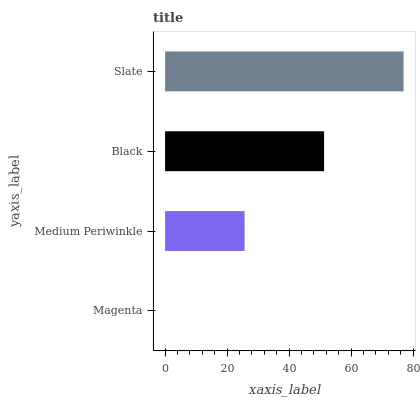Is Magenta the minimum?
Answer yes or no. Yes. Is Slate the maximum?
Answer yes or no. Yes. Is Medium Periwinkle the minimum?
Answer yes or no. No. Is Medium Periwinkle the maximum?
Answer yes or no. No. Is Medium Periwinkle greater than Magenta?
Answer yes or no. Yes. Is Magenta less than Medium Periwinkle?
Answer yes or no. Yes. Is Magenta greater than Medium Periwinkle?
Answer yes or no. No. Is Medium Periwinkle less than Magenta?
Answer yes or no. No. Is Black the high median?
Answer yes or no. Yes. Is Medium Periwinkle the low median?
Answer yes or no. Yes. Is Magenta the high median?
Answer yes or no. No. Is Black the low median?
Answer yes or no. No. 